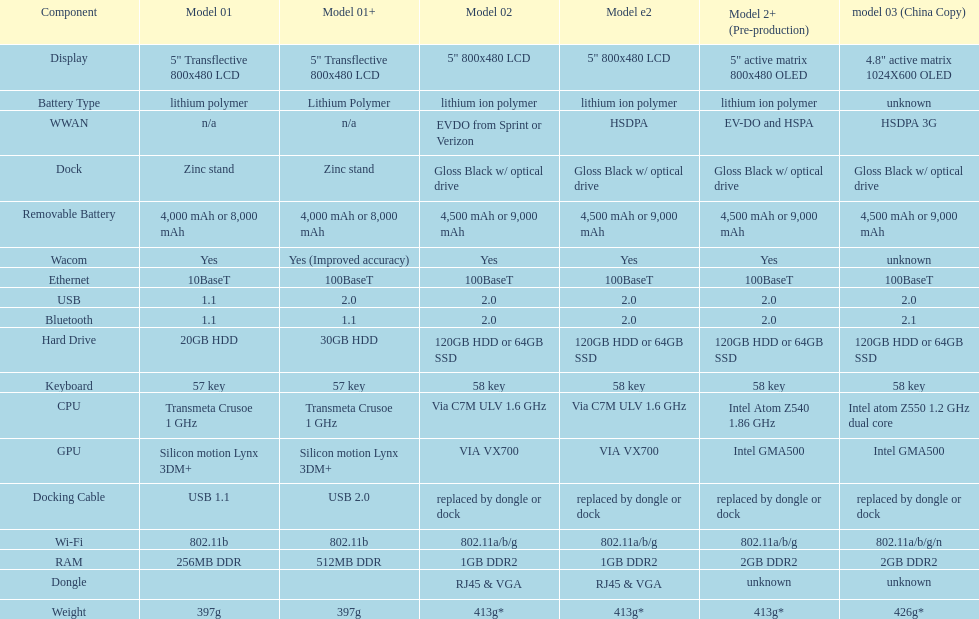Would you mind parsing the complete table? {'header': ['Component', 'Model 01', 'Model 01+', 'Model 02', 'Model e2', 'Model 2+ (Pre-production)', 'model 03 (China Copy)'], 'rows': [['Display', '5" Transflective 800x480 LCD', '5" Transflective 800x480 LCD', '5" 800x480 LCD', '5" 800x480 LCD', '5" active matrix 800x480 OLED', '4.8" active matrix 1024X600 OLED'], ['Battery Type', 'lithium polymer', 'Lithium Polymer', 'lithium ion polymer', 'lithium ion polymer', 'lithium ion polymer', 'unknown'], ['WWAN', 'n/a', 'n/a', 'EVDO from Sprint or Verizon', 'HSDPA', 'EV-DO and HSPA', 'HSDPA 3G'], ['Dock', 'Zinc stand', 'Zinc stand', 'Gloss Black w/ optical drive', 'Gloss Black w/ optical drive', 'Gloss Black w/ optical drive', 'Gloss Black w/ optical drive'], ['Removable Battery', '4,000 mAh or 8,000 mAh', '4,000 mAh or 8,000 mAh', '4,500 mAh or 9,000 mAh', '4,500 mAh or 9,000 mAh', '4,500 mAh or 9,000 mAh', '4,500 mAh or 9,000 mAh'], ['Wacom', 'Yes', 'Yes (Improved accuracy)', 'Yes', 'Yes', 'Yes', 'unknown'], ['Ethernet', '10BaseT', '100BaseT', '100BaseT', '100BaseT', '100BaseT', '100BaseT'], ['USB', '1.1', '2.0', '2.0', '2.0', '2.0', '2.0'], ['Bluetooth', '1.1', '1.1', '2.0', '2.0', '2.0', '2.1'], ['Hard Drive', '20GB HDD', '30GB HDD', '120GB HDD or 64GB SSD', '120GB HDD or 64GB SSD', '120GB HDD or 64GB SSD', '120GB HDD or 64GB SSD'], ['Keyboard', '57 key', '57 key', '58 key', '58 key', '58 key', '58 key'], ['CPU', 'Transmeta Crusoe 1\xa0GHz', 'Transmeta Crusoe 1\xa0GHz', 'Via C7M ULV 1.6\xa0GHz', 'Via C7M ULV 1.6\xa0GHz', 'Intel Atom Z540 1.86\xa0GHz', 'Intel atom Z550 1.2\xa0GHz dual core'], ['GPU', 'Silicon motion Lynx 3DM+', 'Silicon motion Lynx 3DM+', 'VIA VX700', 'VIA VX700', 'Intel GMA500', 'Intel GMA500'], ['Docking Cable', 'USB 1.1', 'USB 2.0', 'replaced by dongle or dock', 'replaced by dongle or dock', 'replaced by dongle or dock', 'replaced by dongle or dock'], ['Wi-Fi', '802.11b', '802.11b', '802.11a/b/g', '802.11a/b/g', '802.11a/b/g', '802.11a/b/g/n'], ['RAM', '256MB DDR', '512MB DDR', '1GB DDR2', '1GB DDR2', '2GB DDR2', '2GB DDR2'], ['Dongle', '', '', 'RJ45 & VGA', 'RJ45 & VGA', 'unknown', 'unknown'], ['Weight', '397g', '397g', '413g*', '413g*', '413g*', '426g*']]} How much more weight does the model 3 have over model 1? 29g. 